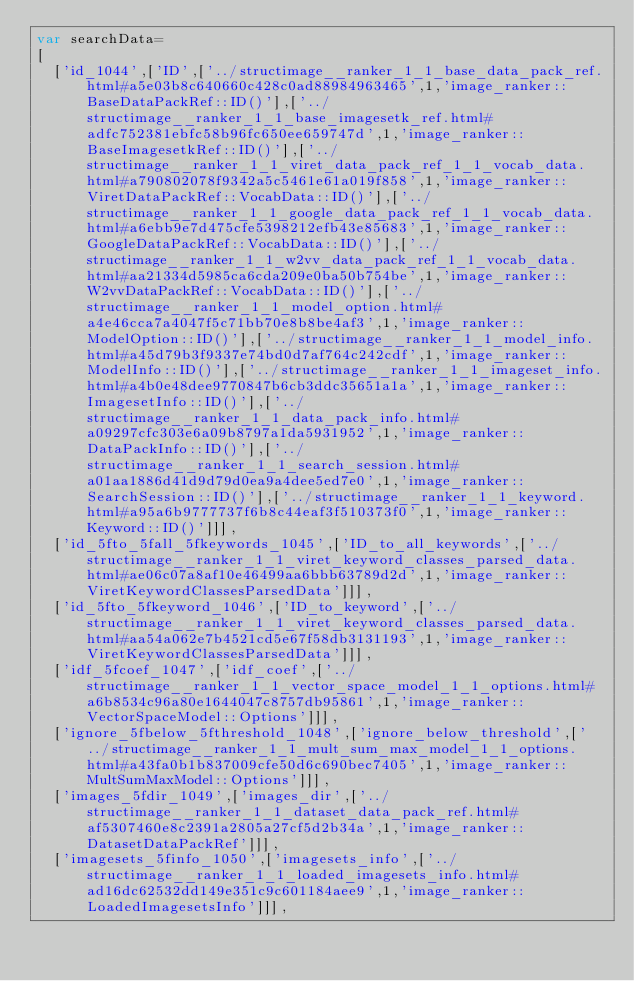<code> <loc_0><loc_0><loc_500><loc_500><_JavaScript_>var searchData=
[
  ['id_1044',['ID',['../structimage__ranker_1_1_base_data_pack_ref.html#a5e03b8c640660c428c0ad88984963465',1,'image_ranker::BaseDataPackRef::ID()'],['../structimage__ranker_1_1_base_imagesetk_ref.html#adfc752381ebfc58b96fc650ee659747d',1,'image_ranker::BaseImagesetkRef::ID()'],['../structimage__ranker_1_1_viret_data_pack_ref_1_1_vocab_data.html#a790802078f9342a5c5461e61a019f858',1,'image_ranker::ViretDataPackRef::VocabData::ID()'],['../structimage__ranker_1_1_google_data_pack_ref_1_1_vocab_data.html#a6ebb9e7d475cfe5398212efb43e85683',1,'image_ranker::GoogleDataPackRef::VocabData::ID()'],['../structimage__ranker_1_1_w2vv_data_pack_ref_1_1_vocab_data.html#aa21334d5985ca6cda209e0ba50b754be',1,'image_ranker::W2vvDataPackRef::VocabData::ID()'],['../structimage__ranker_1_1_model_option.html#a4e46cca7a4047f5c71bb70e8b8be4af3',1,'image_ranker::ModelOption::ID()'],['../structimage__ranker_1_1_model_info.html#a45d79b3f9337e74bd0d7af764c242cdf',1,'image_ranker::ModelInfo::ID()'],['../structimage__ranker_1_1_imageset_info.html#a4b0e48dee9770847b6cb3ddc35651a1a',1,'image_ranker::ImagesetInfo::ID()'],['../structimage__ranker_1_1_data_pack_info.html#a09297cfc303e6a09b8797a1da5931952',1,'image_ranker::DataPackInfo::ID()'],['../structimage__ranker_1_1_search_session.html#a01aa1886d41d9d79d0ea9a4dee5ed7e0',1,'image_ranker::SearchSession::ID()'],['../structimage__ranker_1_1_keyword.html#a95a6b9777737f6b8c44eaf3f510373f0',1,'image_ranker::Keyword::ID()']]],
  ['id_5fto_5fall_5fkeywords_1045',['ID_to_all_keywords',['../structimage__ranker_1_1_viret_keyword_classes_parsed_data.html#ae06c07a8af10e46499aa6bbb63789d2d',1,'image_ranker::ViretKeywordClassesParsedData']]],
  ['id_5fto_5fkeyword_1046',['ID_to_keyword',['../structimage__ranker_1_1_viret_keyword_classes_parsed_data.html#aa54a062e7b4521cd5e67f58db3131193',1,'image_ranker::ViretKeywordClassesParsedData']]],
  ['idf_5fcoef_1047',['idf_coef',['../structimage__ranker_1_1_vector_space_model_1_1_options.html#a6b8534c96a80e1644047c8757db95861',1,'image_ranker::VectorSpaceModel::Options']]],
  ['ignore_5fbelow_5fthreshold_1048',['ignore_below_threshold',['../structimage__ranker_1_1_mult_sum_max_model_1_1_options.html#a43fa0b1b837009cfe50d6c690bec7405',1,'image_ranker::MultSumMaxModel::Options']]],
  ['images_5fdir_1049',['images_dir',['../structimage__ranker_1_1_dataset_data_pack_ref.html#af5307460e8c2391a2805a27cf5d2b34a',1,'image_ranker::DatasetDataPackRef']]],
  ['imagesets_5finfo_1050',['imagesets_info',['../structimage__ranker_1_1_loaded_imagesets_info.html#ad16dc62532dd149e351c9c601184aee9',1,'image_ranker::LoadedImagesetsInfo']]],</code> 